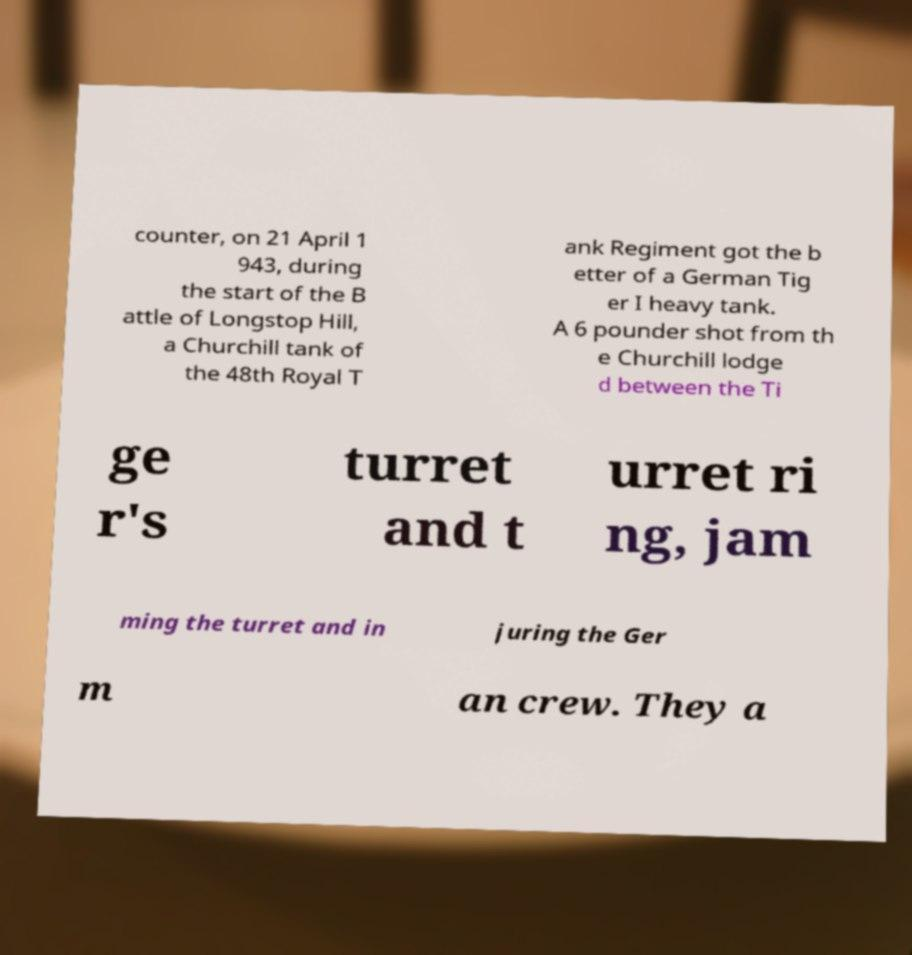Could you assist in decoding the text presented in this image and type it out clearly? counter, on 21 April 1 943, during the start of the B attle of Longstop Hill, a Churchill tank of the 48th Royal T ank Regiment got the b etter of a German Tig er I heavy tank. A 6 pounder shot from th e Churchill lodge d between the Ti ge r's turret and t urret ri ng, jam ming the turret and in juring the Ger m an crew. They a 